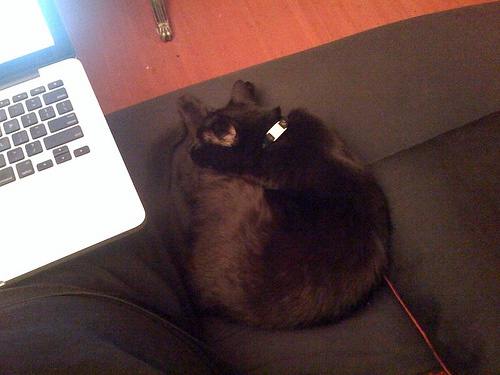Describe the objects in this image and their specific colors. I can see couch in white, black, maroon, and brown tones, cat in white, black, maroon, and brown tones, laptop in white, darkgray, gray, and lightblue tones, and keyboard in white, darkgray, and gray tones in this image. 